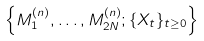<formula> <loc_0><loc_0><loc_500><loc_500>\left \{ M _ { 1 } ^ { \left ( n \right ) } , \dots , M _ { 2 N } ^ { ( n ) } ; \{ X _ { t } \} _ { t \geq 0 } \right \}</formula> 